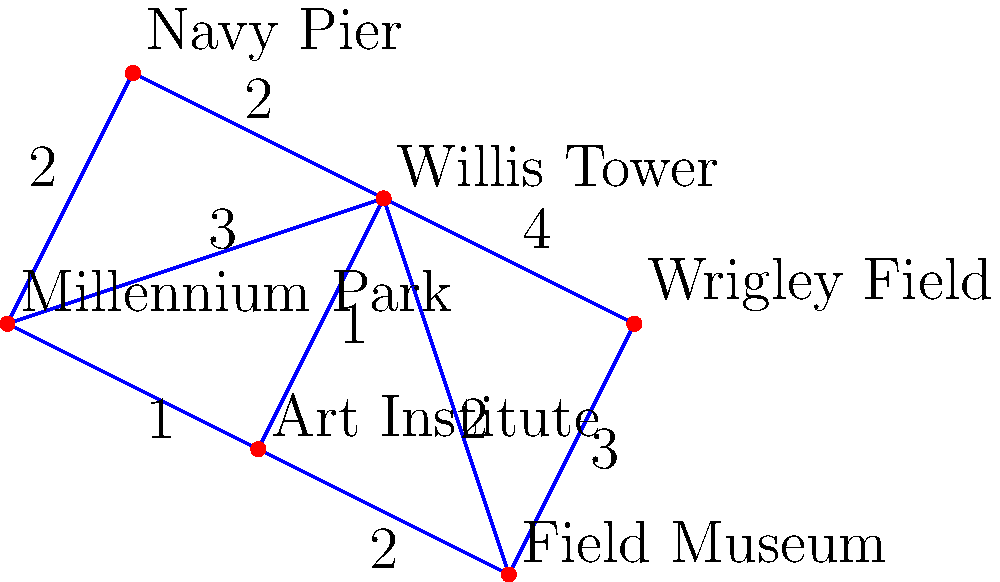As a cabdriver in Chicago, you need to find the shortest route from Millennium Park to Wrigley Field. Using the city map graph provided, where vertices represent landmarks and edge weights represent travel time in minutes, what is the minimum time required to reach Wrigley Field from Millennium Park? To find the shortest route from Millennium Park to Wrigley Field, we'll use Dijkstra's algorithm:

1. Start at Millennium Park (MP).
2. Initialize distances: MP = 0, all others = infinity.
3. Visit unvisited vertices with smallest known distance:

   a) MP → Art Institute (AI): 1 min
   b) MP → Willis Tower (WT): 3 min
   c) MP → Navy Pier (NP): 2 min

4. Update distances:
   AI: 1 min, WT: 3 min, NP: 2 min

5. Visit AI (smallest unvisited):
   a) AI → Field Museum (FM): 1 + 2 = 3 min
   b) AI → WT: 1 + 1 = 2 min (shorter than current 3 min)

6. Update distances:
   WT: 2 min, NP: 2 min, FM: 3 min

7. Visit WT (smallest unvisited):
   a) WT → Wrigley Field (WF): 2 + 4 = 6 min

8. Update distances:
   NP: 2 min, FM: 3 min, WF: 6 min

9. Visit NP, then FM (no shorter paths found)

10. WF remains the shortest at 6 minutes.

The shortest path is: Millennium Park → Art Institute → Willis Tower → Wrigley Field, taking 6 minutes.
Answer: 6 minutes 